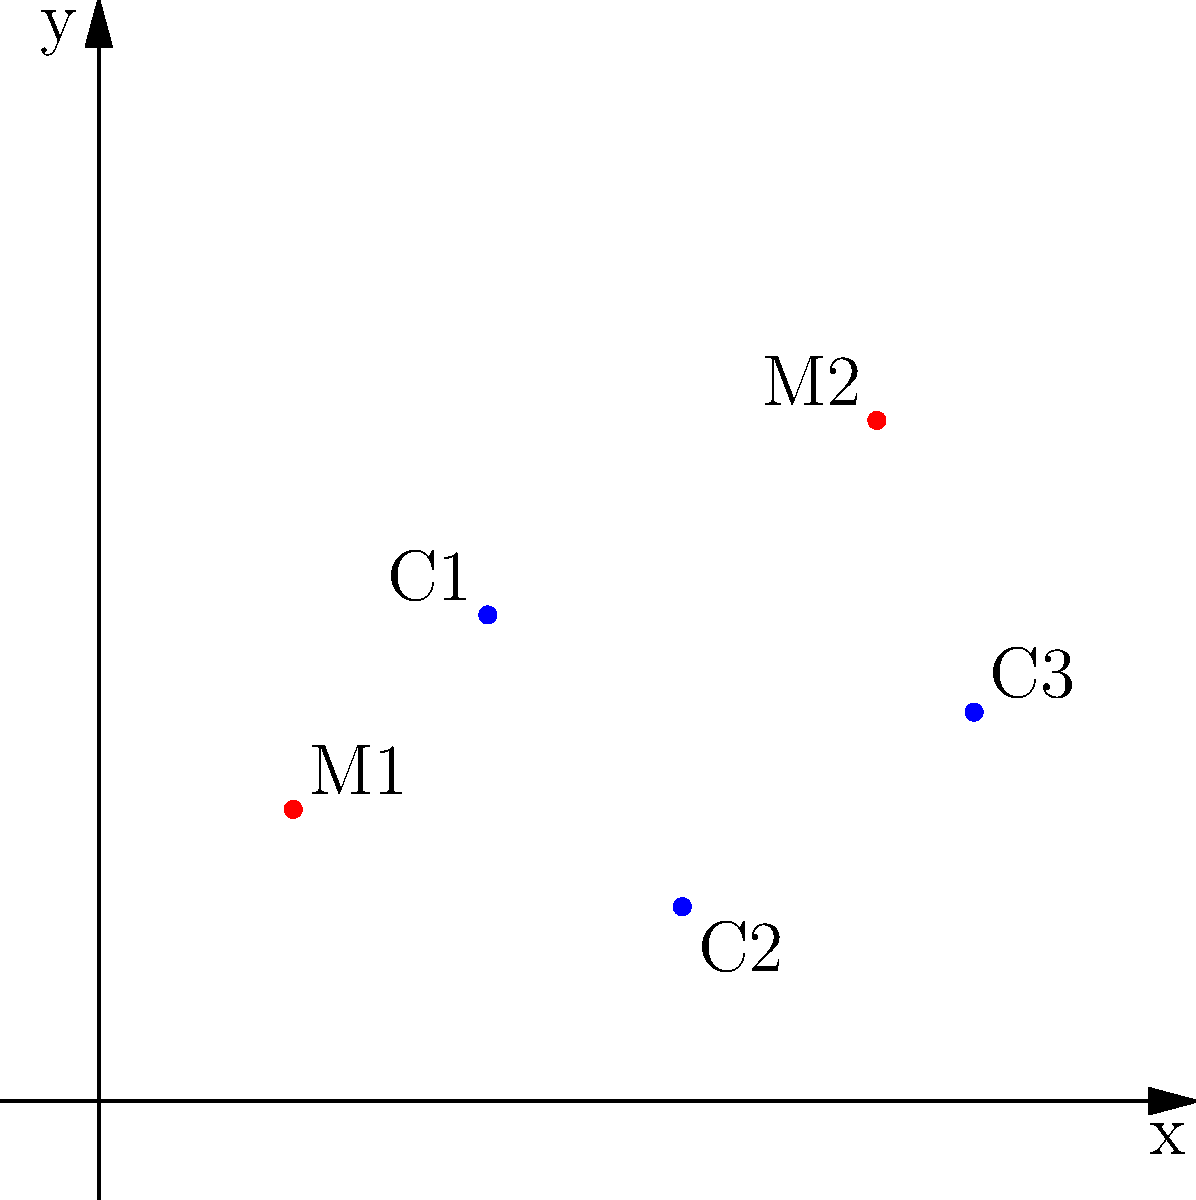Given the 2D grid above representing mining sites (red dots) and local communities (blue dots), which community is closest to mining site M2 located at (8,7)? Calculate the distance using the Euclidean distance formula: $d = \sqrt{(x_2-x_1)^2 + (y_2-y_1)^2}$. To find the closest community to mining site M2, we need to calculate the distance between M2 and each community using the Euclidean distance formula.

1. Distance between M2 and C1:
   M2(8,7), C1(4,5)
   $d = \sqrt{(8-4)^2 + (7-5)^2} = \sqrt{16 + 4} = \sqrt{20} \approx 4.47$

2. Distance between M2 and C2:
   M2(8,7), C2(6,2)
   $d = \sqrt{(8-6)^2 + (7-2)^2} = \sqrt{4 + 25} = \sqrt{29} \approx 5.39$

3. Distance between M2 and C3:
   M2(8,7), C3(9,4)
   $d = \sqrt{(8-9)^2 + (7-4)^2} = \sqrt{1 + 9} = \sqrt{10} \approx 3.16$

The smallest distance is between M2 and C3, approximately 3.16 units.
Answer: C3 